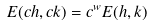<formula> <loc_0><loc_0><loc_500><loc_500>E ( c h , c k ) = c ^ { w } E ( h , k )</formula> 